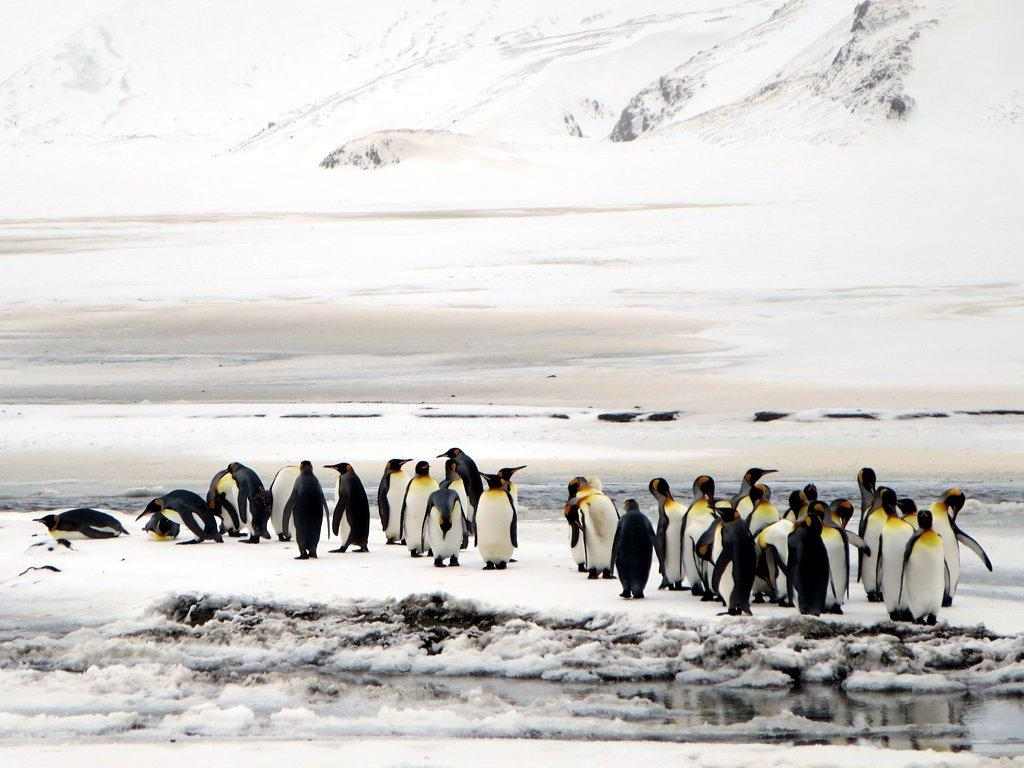What type of animals are present in the image? There are penguins in the image. Where are the penguins located in the image? The penguins are located at the bottom of the image. What type of terrain is visible in the background of the image? There is a snow ground in the background of the image. What other feature can be seen in the image? There is a snow mountain in the image. Where is the snow mountain located in the image? The snow mountain is located at the top of the image. What type of cherry tree can be seen growing on the snow mountain in the image? There is no cherry tree present in the image; the snow mountain is the only feature visible at the top of the image. 